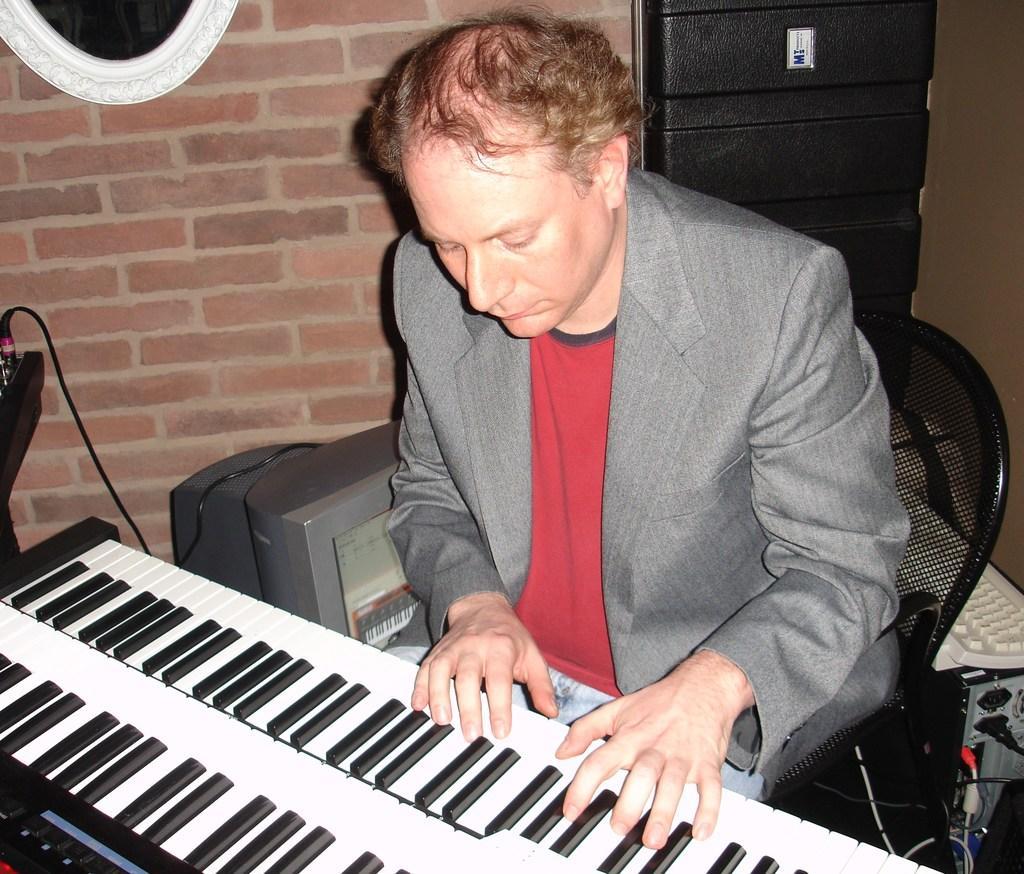How would you summarize this image in a sentence or two? In this image a man sitting on a chair and playing some musical instrument ,beside a man there is a desk top at the background there is a wall. 